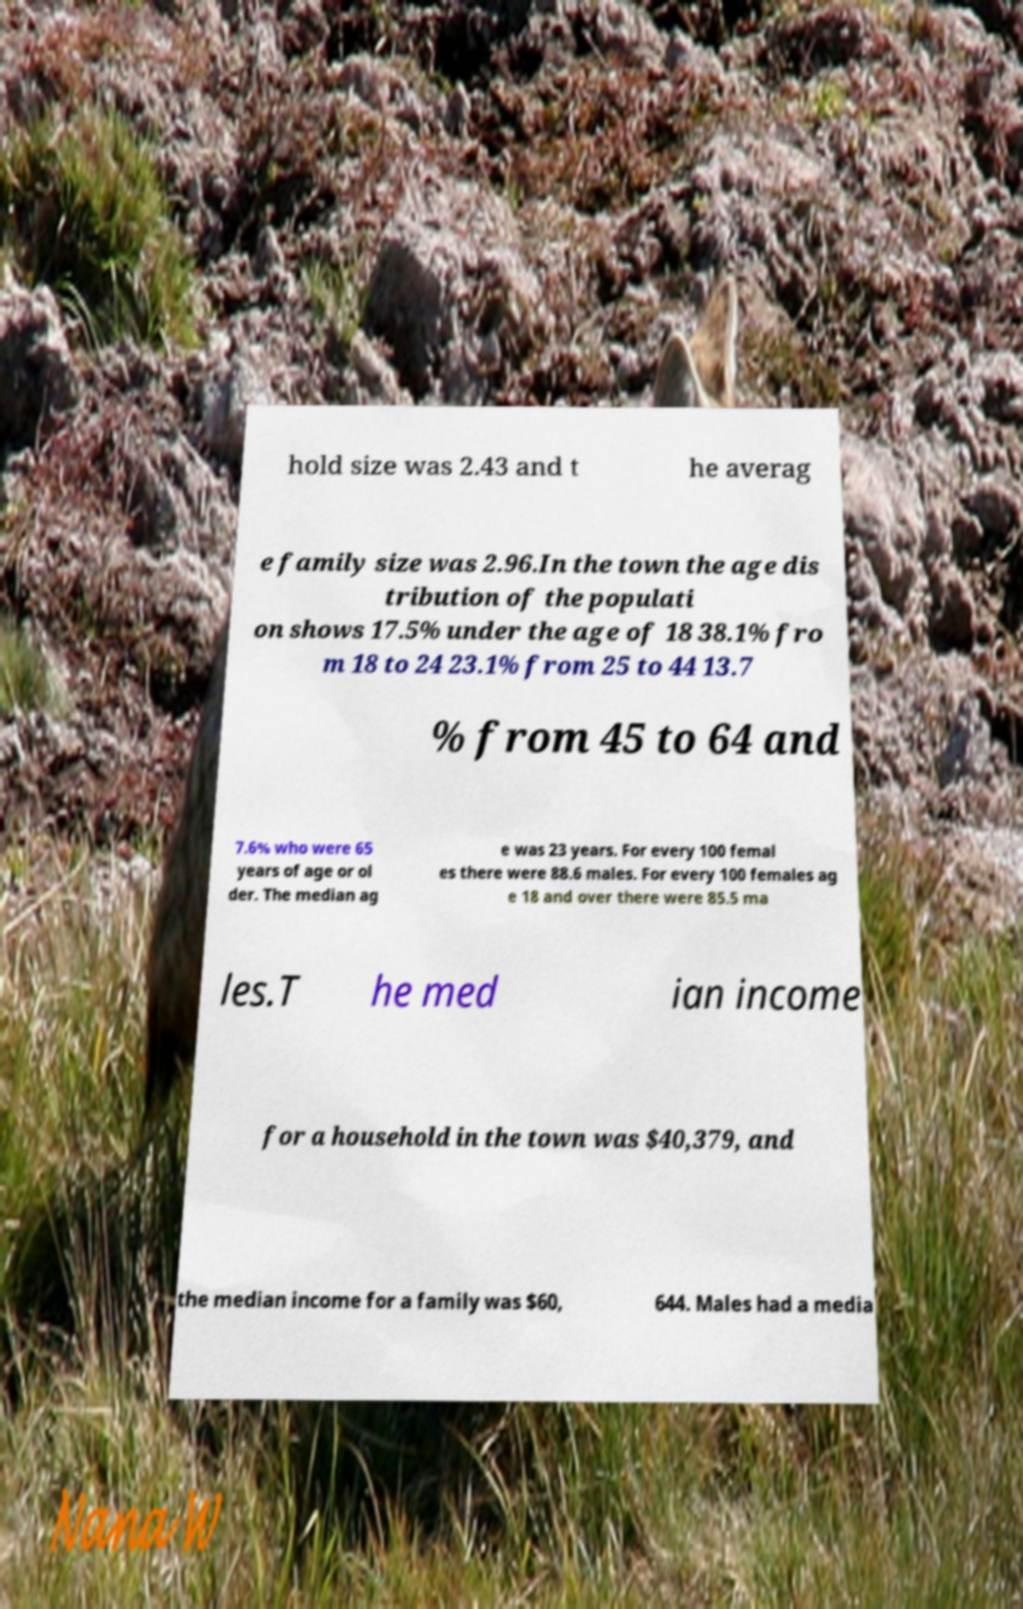Please identify and transcribe the text found in this image. hold size was 2.43 and t he averag e family size was 2.96.In the town the age dis tribution of the populati on shows 17.5% under the age of 18 38.1% fro m 18 to 24 23.1% from 25 to 44 13.7 % from 45 to 64 and 7.6% who were 65 years of age or ol der. The median ag e was 23 years. For every 100 femal es there were 88.6 males. For every 100 females ag e 18 and over there were 85.5 ma les.T he med ian income for a household in the town was $40,379, and the median income for a family was $60, 644. Males had a media 